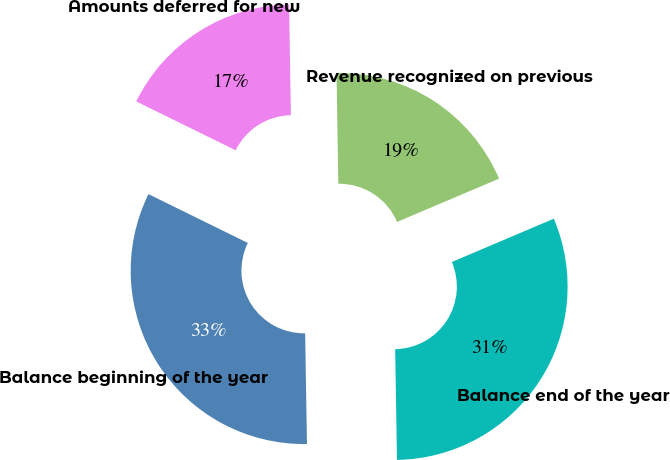<chart> <loc_0><loc_0><loc_500><loc_500><pie_chart><fcel>Balance beginning of the year<fcel>Amounts deferred for new<fcel>Revenue recognized on previous<fcel>Balance end of the year<nl><fcel>32.53%<fcel>17.47%<fcel>18.87%<fcel>31.13%<nl></chart> 